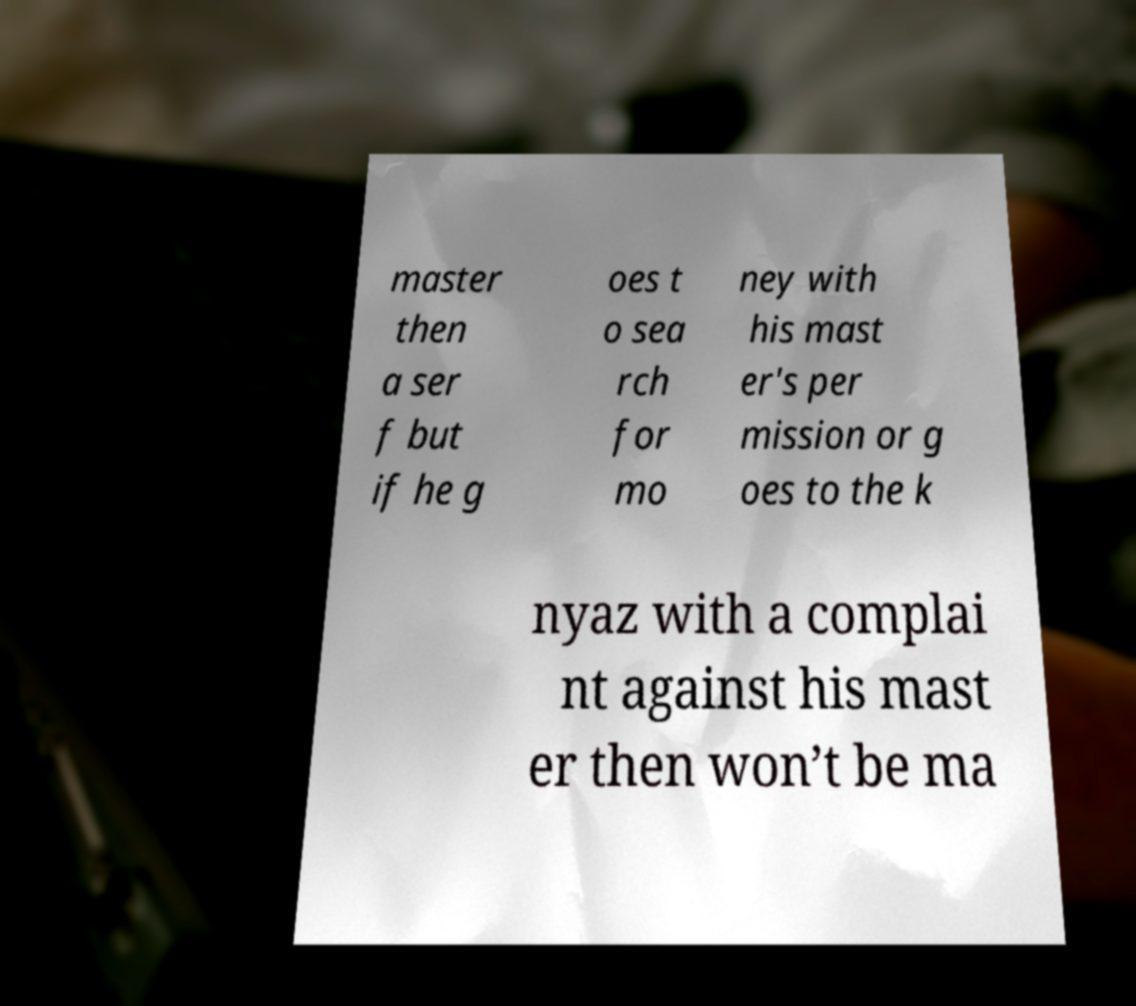Can you read and provide the text displayed in the image?This photo seems to have some interesting text. Can you extract and type it out for me? master then a ser f but if he g oes t o sea rch for mo ney with his mast er's per mission or g oes to the k nyaz with a complai nt against his mast er then won’t be ma 